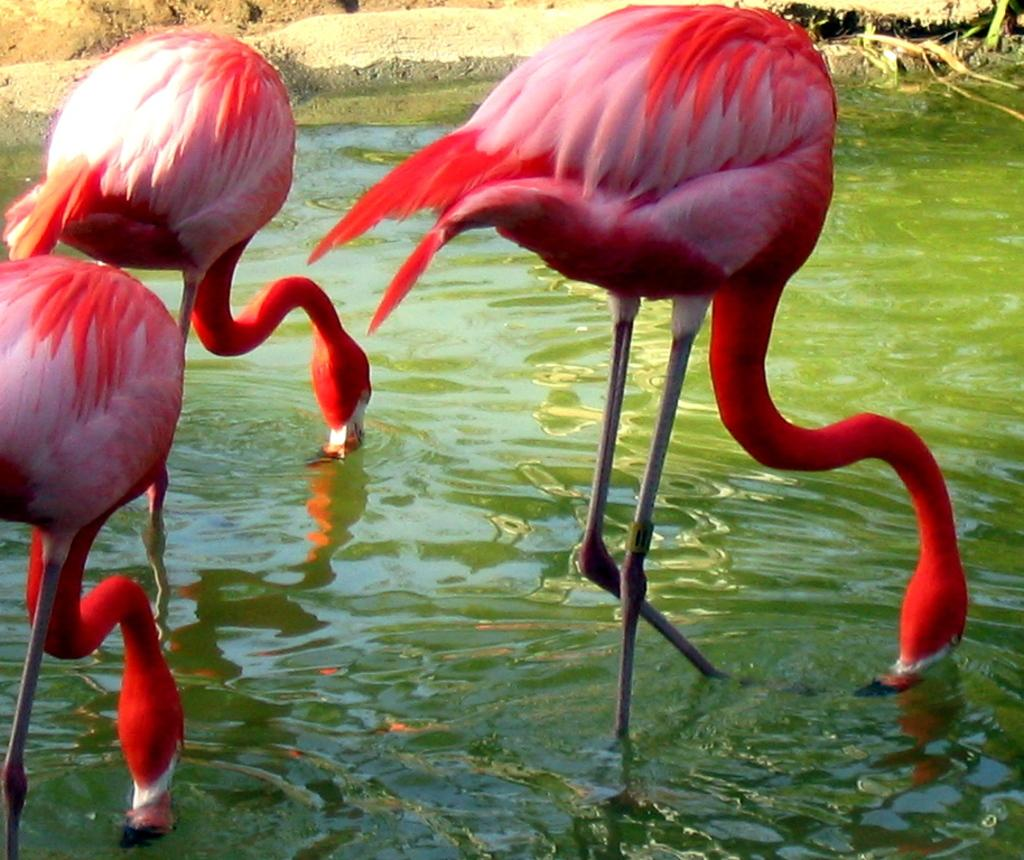How many birds are present in the image? There are three birds in the image. What color are the birds? The birds are red in color. Where are the birds located in the image? The birds are in the water. What type of bird do the birds in the image resemble? The birds resemble cranes. What type of copper material can be seen in the room in the image? There is no copper material or room present in the image; it features three red birds in the water. 